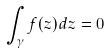<formula> <loc_0><loc_0><loc_500><loc_500>\int _ { \gamma } f ( z ) d z = 0</formula> 